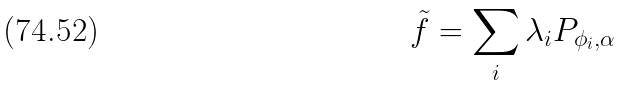<formula> <loc_0><loc_0><loc_500><loc_500>\tilde { f } = \sum _ { i } \lambda _ { i } P _ { \phi _ { i } , \alpha }</formula> 